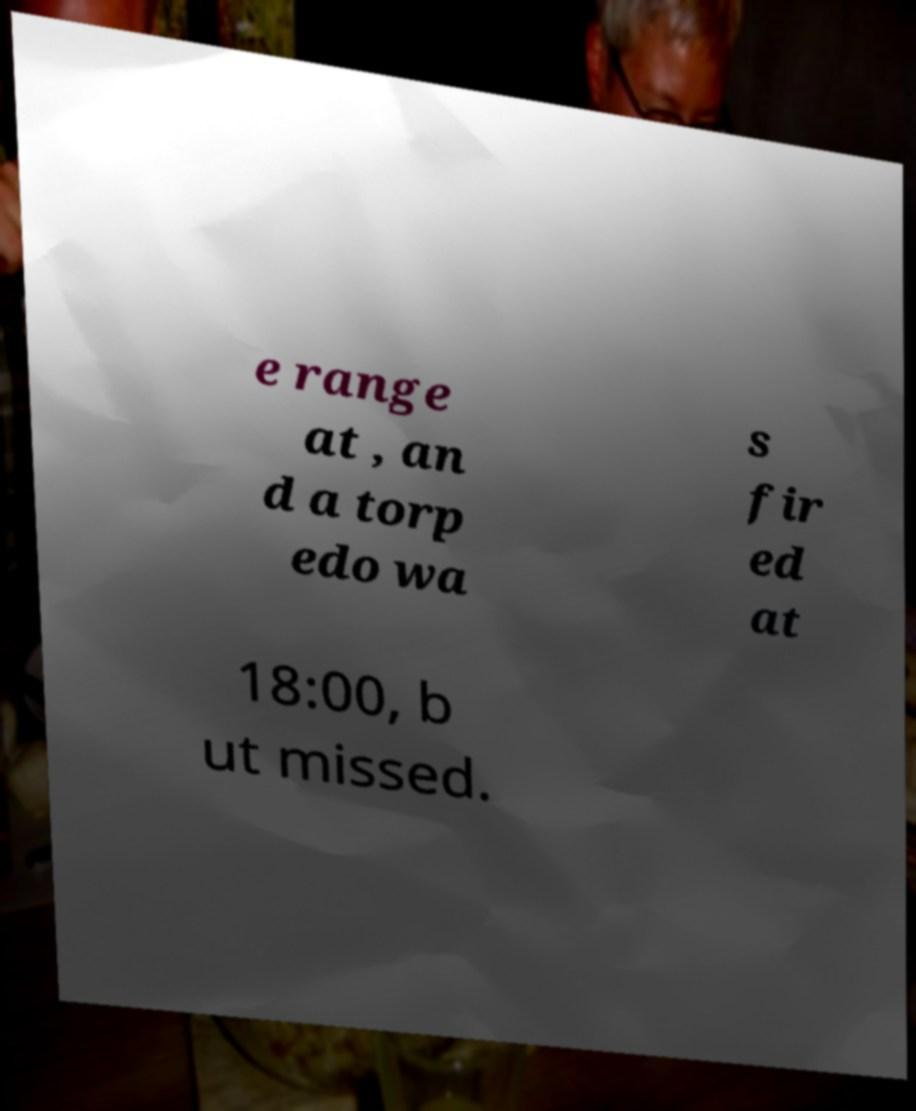What messages or text are displayed in this image? I need them in a readable, typed format. e range at , an d a torp edo wa s fir ed at 18:00, b ut missed. 